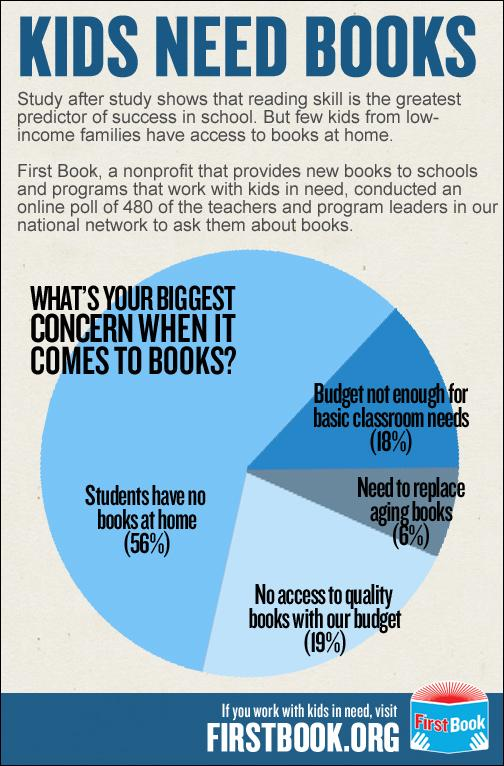Specify some key components in this picture. According to the information, approximately 6% of the existing books need to be replaced due to aging. A study found that 62% of students who do not have any books at home and require replacements for their aging books. The book image contains text that reads "FirstBook.. It is not a concern when it comes to books, but rather the need to replace aging books. 